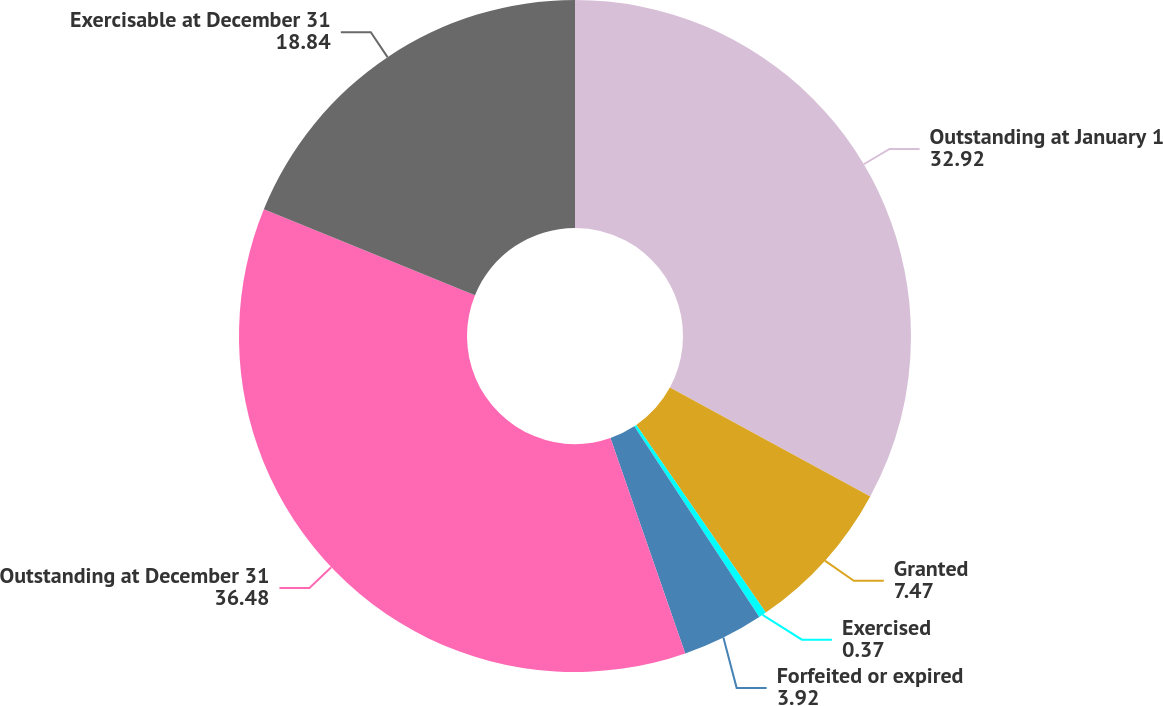<chart> <loc_0><loc_0><loc_500><loc_500><pie_chart><fcel>Outstanding at January 1<fcel>Granted<fcel>Exercised<fcel>Forfeited or expired<fcel>Outstanding at December 31<fcel>Exercisable at December 31<nl><fcel>32.92%<fcel>7.47%<fcel>0.37%<fcel>3.92%<fcel>36.48%<fcel>18.84%<nl></chart> 